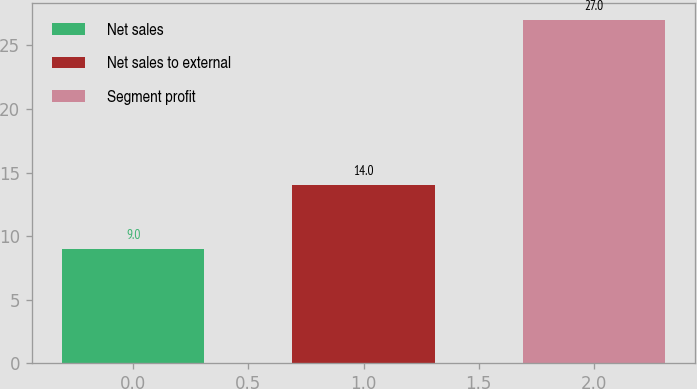Convert chart to OTSL. <chart><loc_0><loc_0><loc_500><loc_500><bar_chart><fcel>Net sales<fcel>Net sales to external<fcel>Segment profit<nl><fcel>9<fcel>14<fcel>27<nl></chart> 